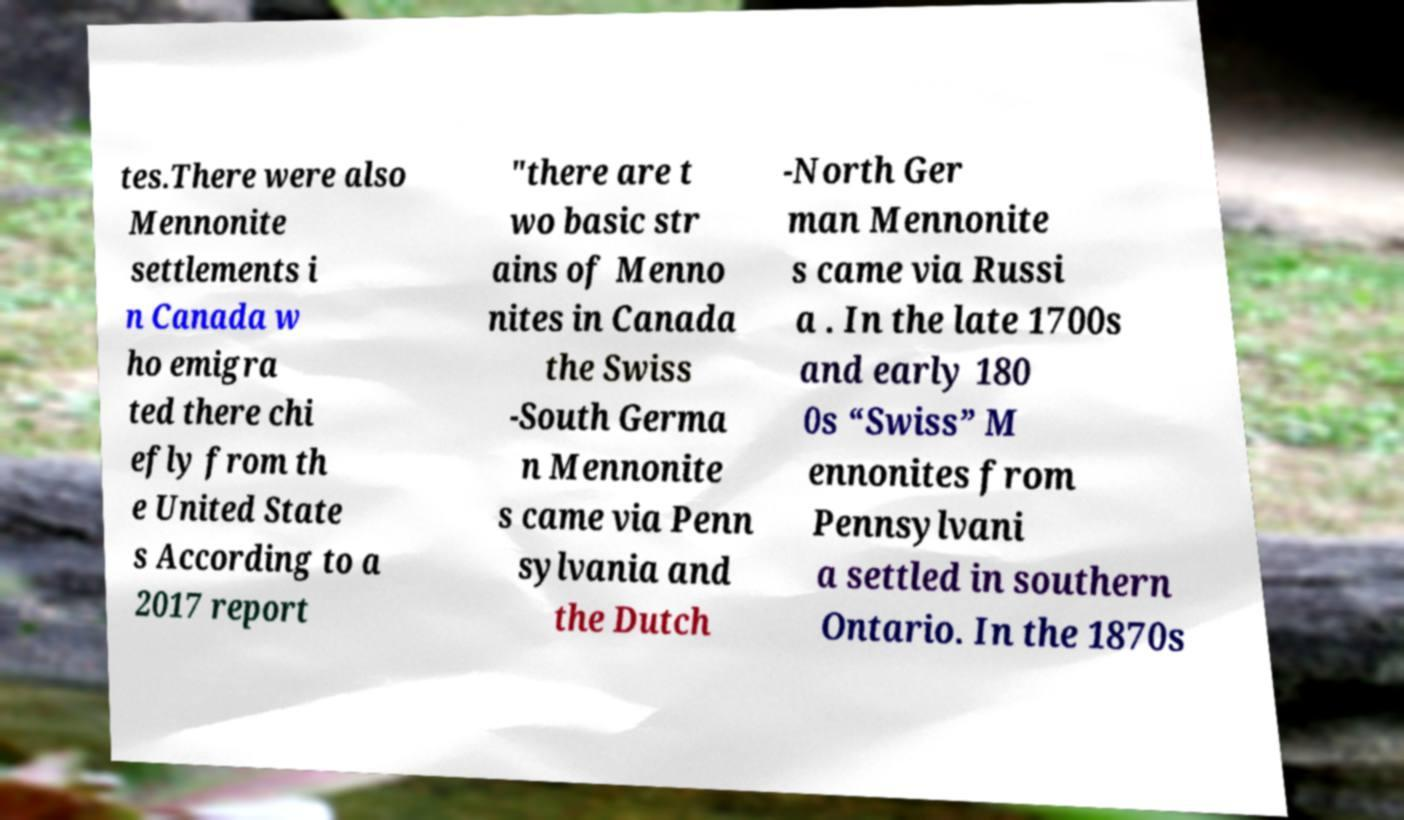There's text embedded in this image that I need extracted. Can you transcribe it verbatim? tes.There were also Mennonite settlements i n Canada w ho emigra ted there chi efly from th e United State s According to a 2017 report "there are t wo basic str ains of Menno nites in Canada the Swiss -South Germa n Mennonite s came via Penn sylvania and the Dutch -North Ger man Mennonite s came via Russi a . In the late 1700s and early 180 0s “Swiss” M ennonites from Pennsylvani a settled in southern Ontario. In the 1870s 